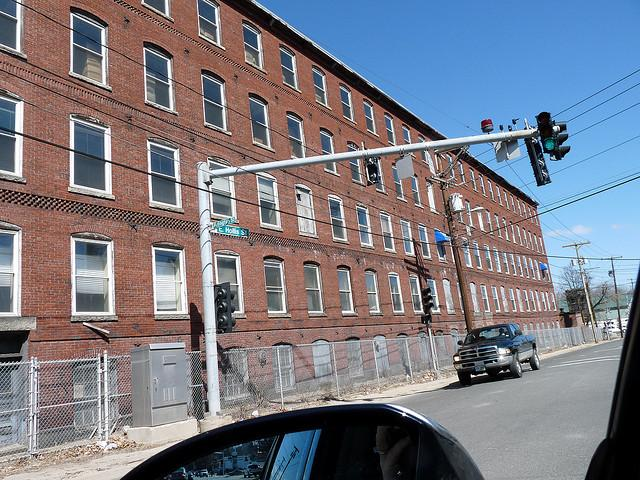What should the vehicle showing the side mirror do in this situation? proceed 